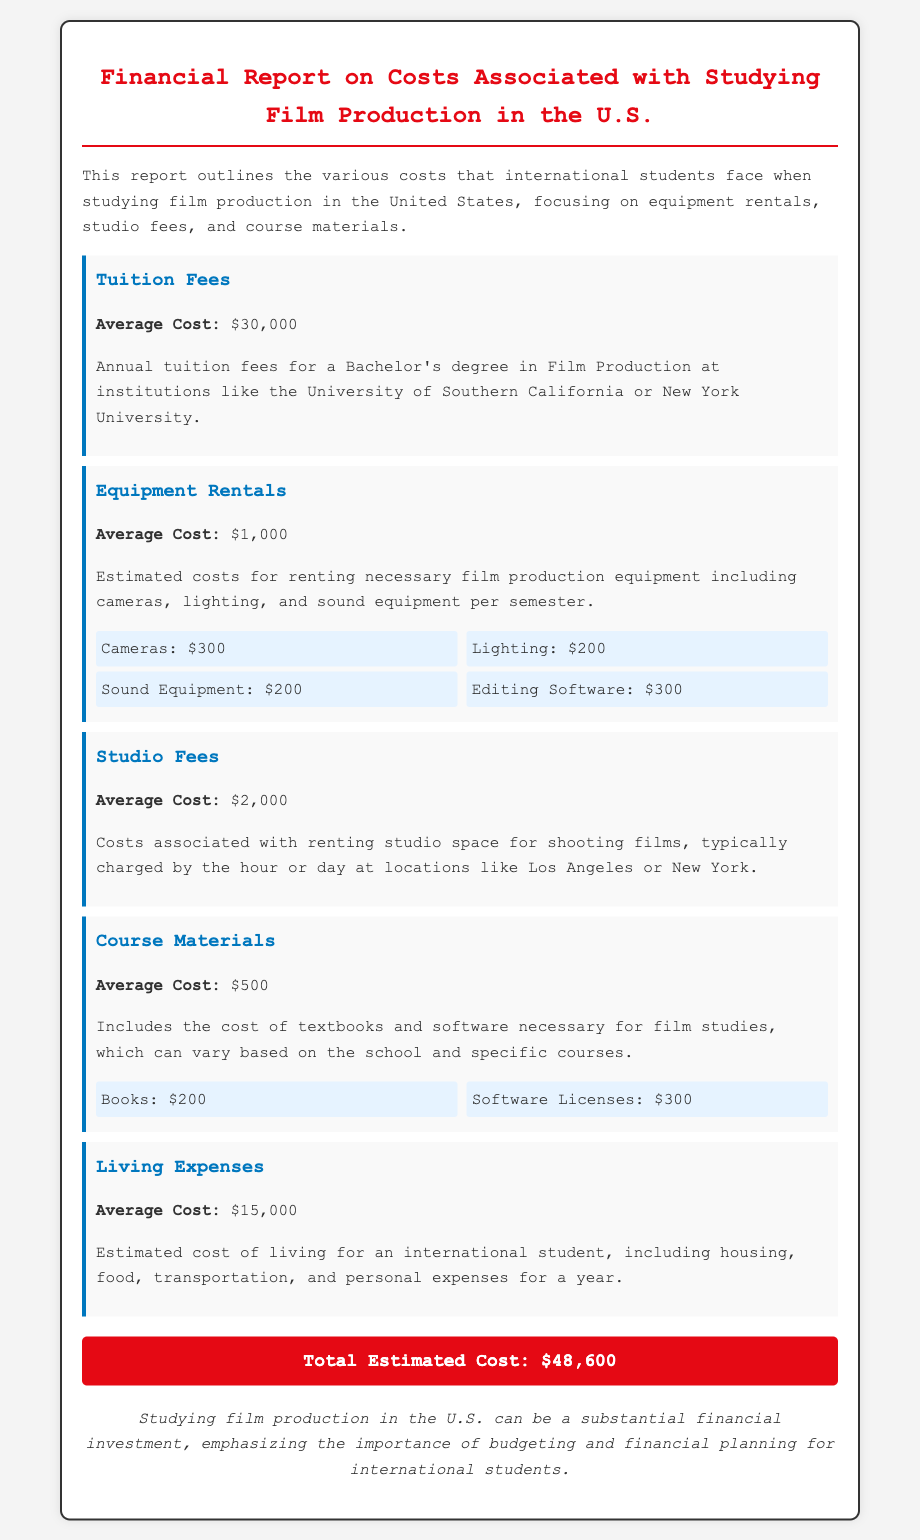What is the average tuition fee? The average tuition fee for a Bachelor's degree in Film Production is $30,000.
Answer: $30,000 How much are estimated equipment rental costs per semester? The estimated equipment rental costs per semester for film production equipment is $1,000.
Answer: $1,000 What is the average cost for studio fees? The average cost for studio fees is $2,000.
Answer: $2,000 What are the total estimated costs associated with studying film production? The total estimated costs associated with studying film production are calculated by adding all individual costs, resulting in $48,600.
Answer: $48,600 How much do living expenses cost on average? The estimated average cost of living for an international student is $15,000.
Answer: $15,000 What are the total costs for books and software licenses? The total cost for books is $200 and for software licenses is $300, giving a combined total of $500 for course materials.
Answer: $500 Which film production school is mentioned in the document? The document mentions institutions like the University of Southern California and New York University.
Answer: University of Southern California or New York University How much does editing software cost as part of equipment rentals? The cost for editing software as part of equipment rentals is $300.
Answer: $300 What is the cost breakdown for sound equipment? The cost for sound equipment rental is $200.
Answer: $200 